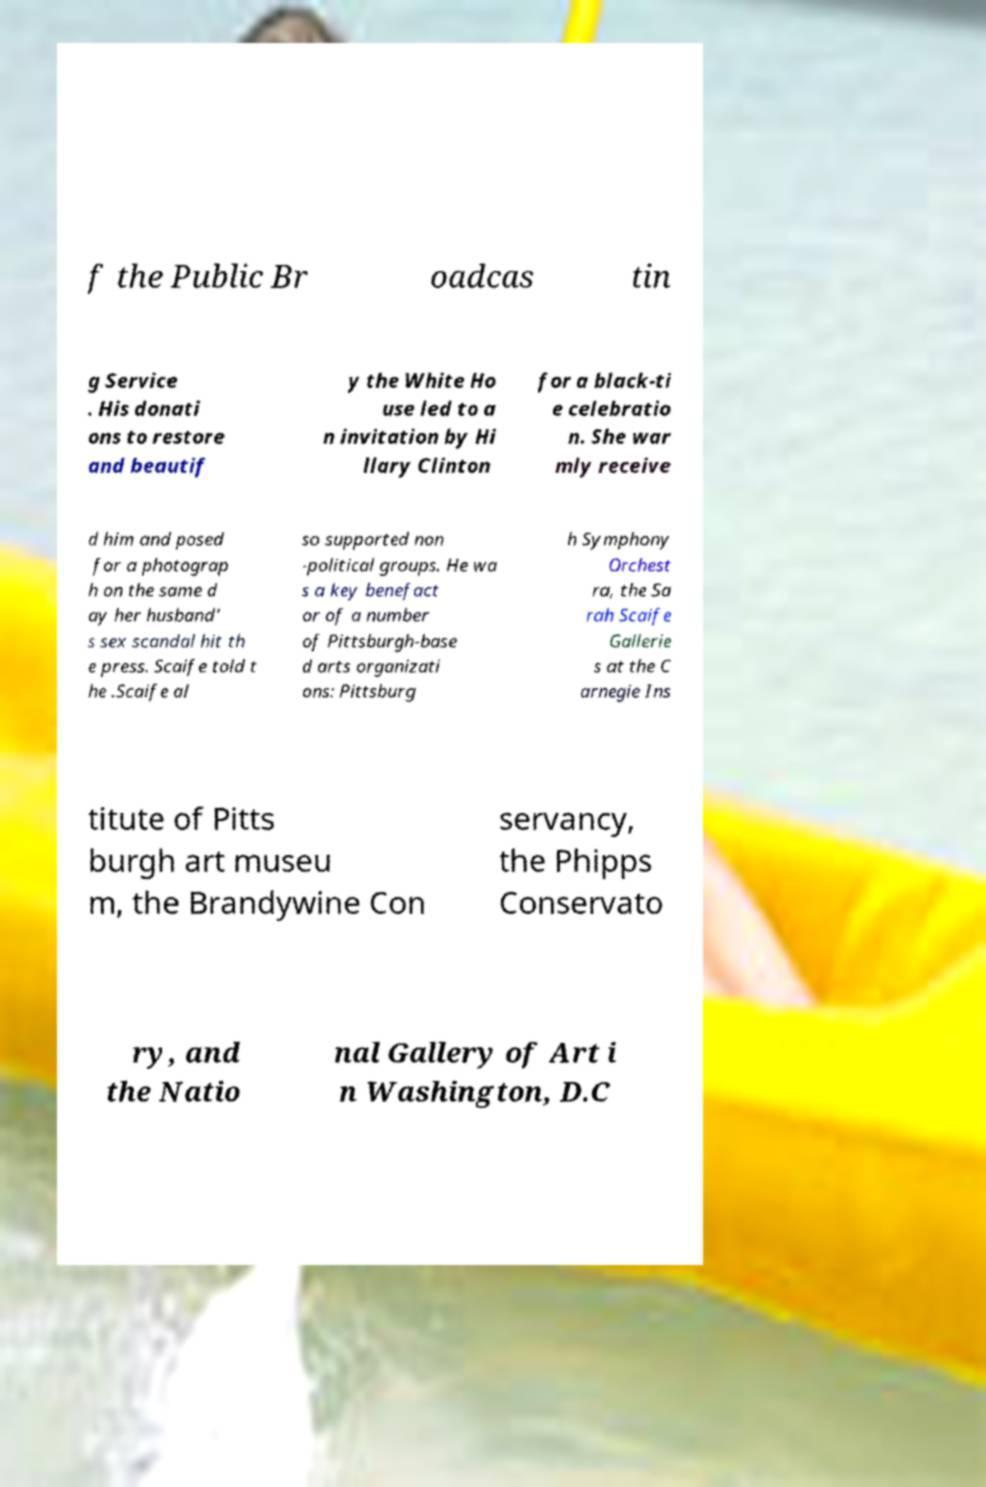What messages or text are displayed in this image? I need them in a readable, typed format. f the Public Br oadcas tin g Service . His donati ons to restore and beautif y the White Ho use led to a n invitation by Hi llary Clinton for a black-ti e celebratio n. She war mly receive d him and posed for a photograp h on the same d ay her husband' s sex scandal hit th e press. Scaife told t he .Scaife al so supported non -political groups. He wa s a key benefact or of a number of Pittsburgh-base d arts organizati ons: Pittsburg h Symphony Orchest ra, the Sa rah Scaife Gallerie s at the C arnegie Ins titute of Pitts burgh art museu m, the Brandywine Con servancy, the Phipps Conservato ry, and the Natio nal Gallery of Art i n Washington, D.C 